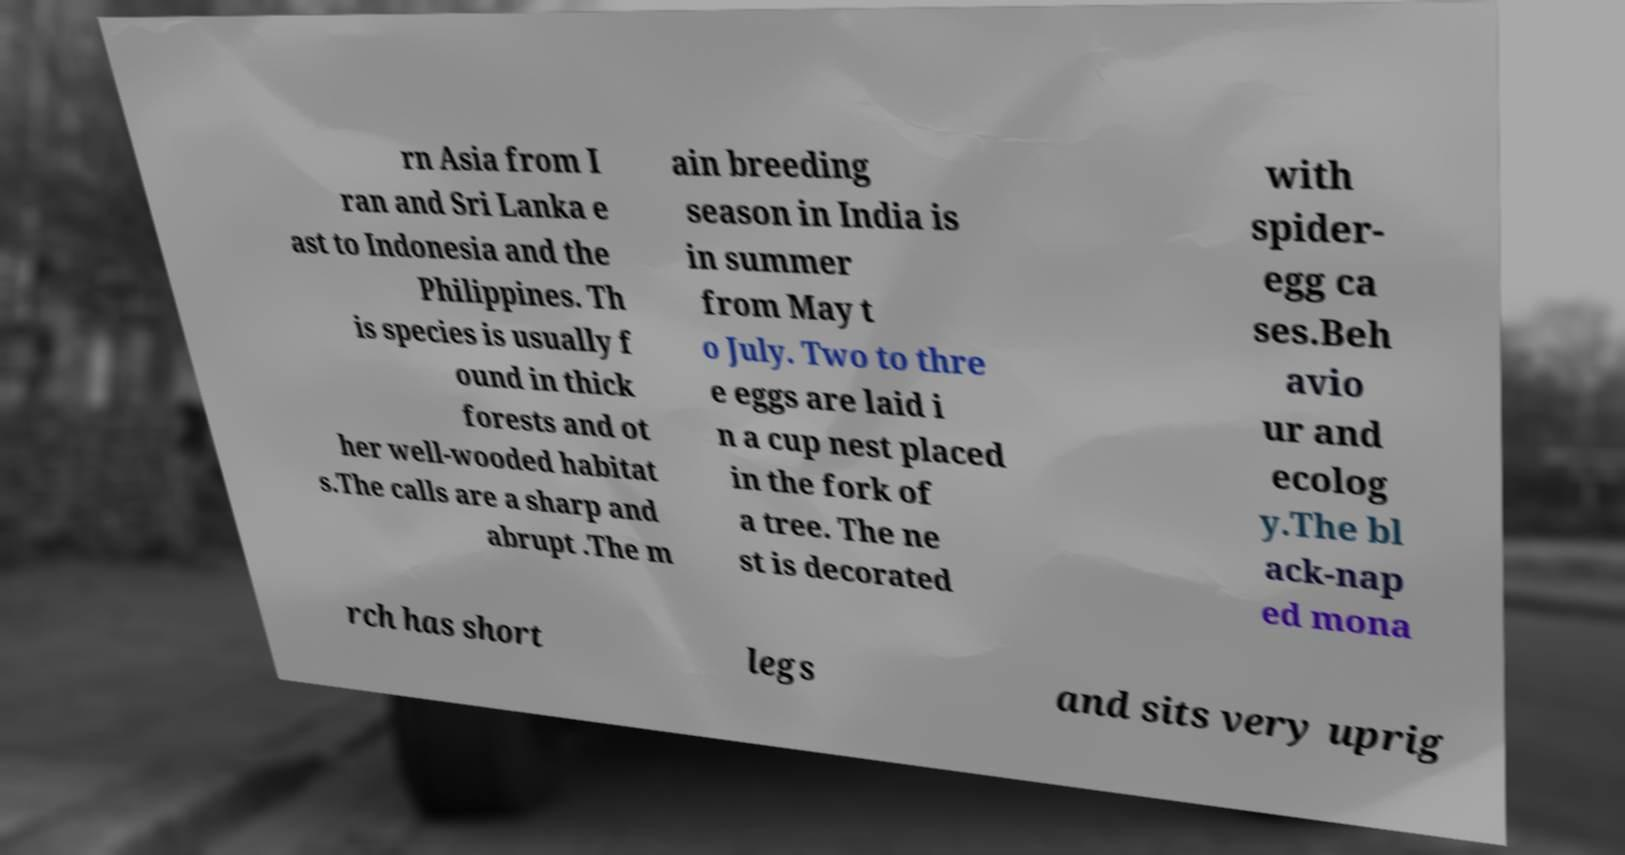Can you read and provide the text displayed in the image?This photo seems to have some interesting text. Can you extract and type it out for me? rn Asia from I ran and Sri Lanka e ast to Indonesia and the Philippines. Th is species is usually f ound in thick forests and ot her well-wooded habitat s.The calls are a sharp and abrupt .The m ain breeding season in India is in summer from May t o July. Two to thre e eggs are laid i n a cup nest placed in the fork of a tree. The ne st is decorated with spider- egg ca ses.Beh avio ur and ecolog y.The bl ack-nap ed mona rch has short legs and sits very uprig 